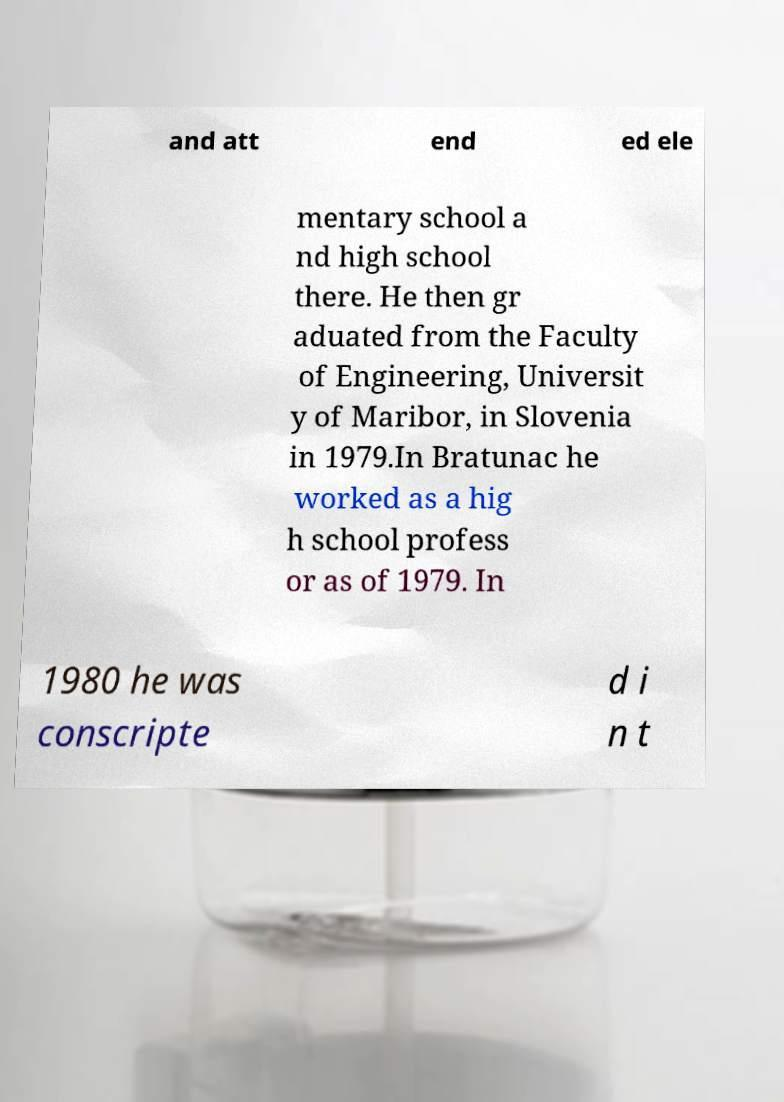What messages or text are displayed in this image? I need them in a readable, typed format. and att end ed ele mentary school a nd high school there. He then gr aduated from the Faculty of Engineering, Universit y of Maribor, in Slovenia in 1979.In Bratunac he worked as a hig h school profess or as of 1979. In 1980 he was conscripte d i n t 